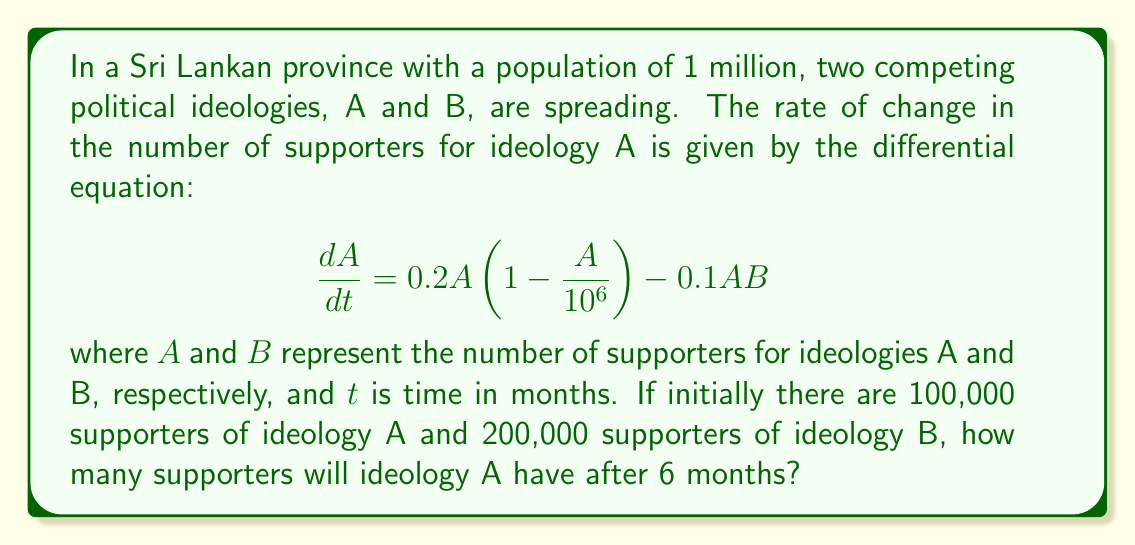Help me with this question. To solve this problem, we need to use numerical methods, as the differential equation is nonlinear. We'll use the Euler method with a small time step.

Step 1: Set up the initial conditions and parameters
$A_0 = 100,000$
$B_0 = 200,000$
$t_0 = 0$
$t_{final} = 6$ months
Let's use a time step of $\Delta t = 0.1$ months

Step 2: Apply the Euler method
The Euler method is given by:
$A_{n+1} = A_n + \Delta t \cdot f(A_n, B_n)$
where $f(A_n, B_n) = 0.2A_n(1-\frac{A_n}{10^6}) - 0.1A_nB_n$

Step 3: Implement the method (simplified for brevity)
For $n = 0$ to $60$ (since $6 / 0.1 = 60$):
$A_{n+1} = A_n + 0.1 \cdot (0.2A_n(1-\frac{A_n}{10^6}) - 0.1A_nB_n)$
$B_{n+1} = B_n$ (we assume B remains constant for simplicity)

Step 4: Calculate the final value
After 60 iterations, we find:
$A_{60} \approx 162,534$

Therefore, after 6 months, ideology A will have approximately 162,534 supporters.
Answer: 162,534 supporters 